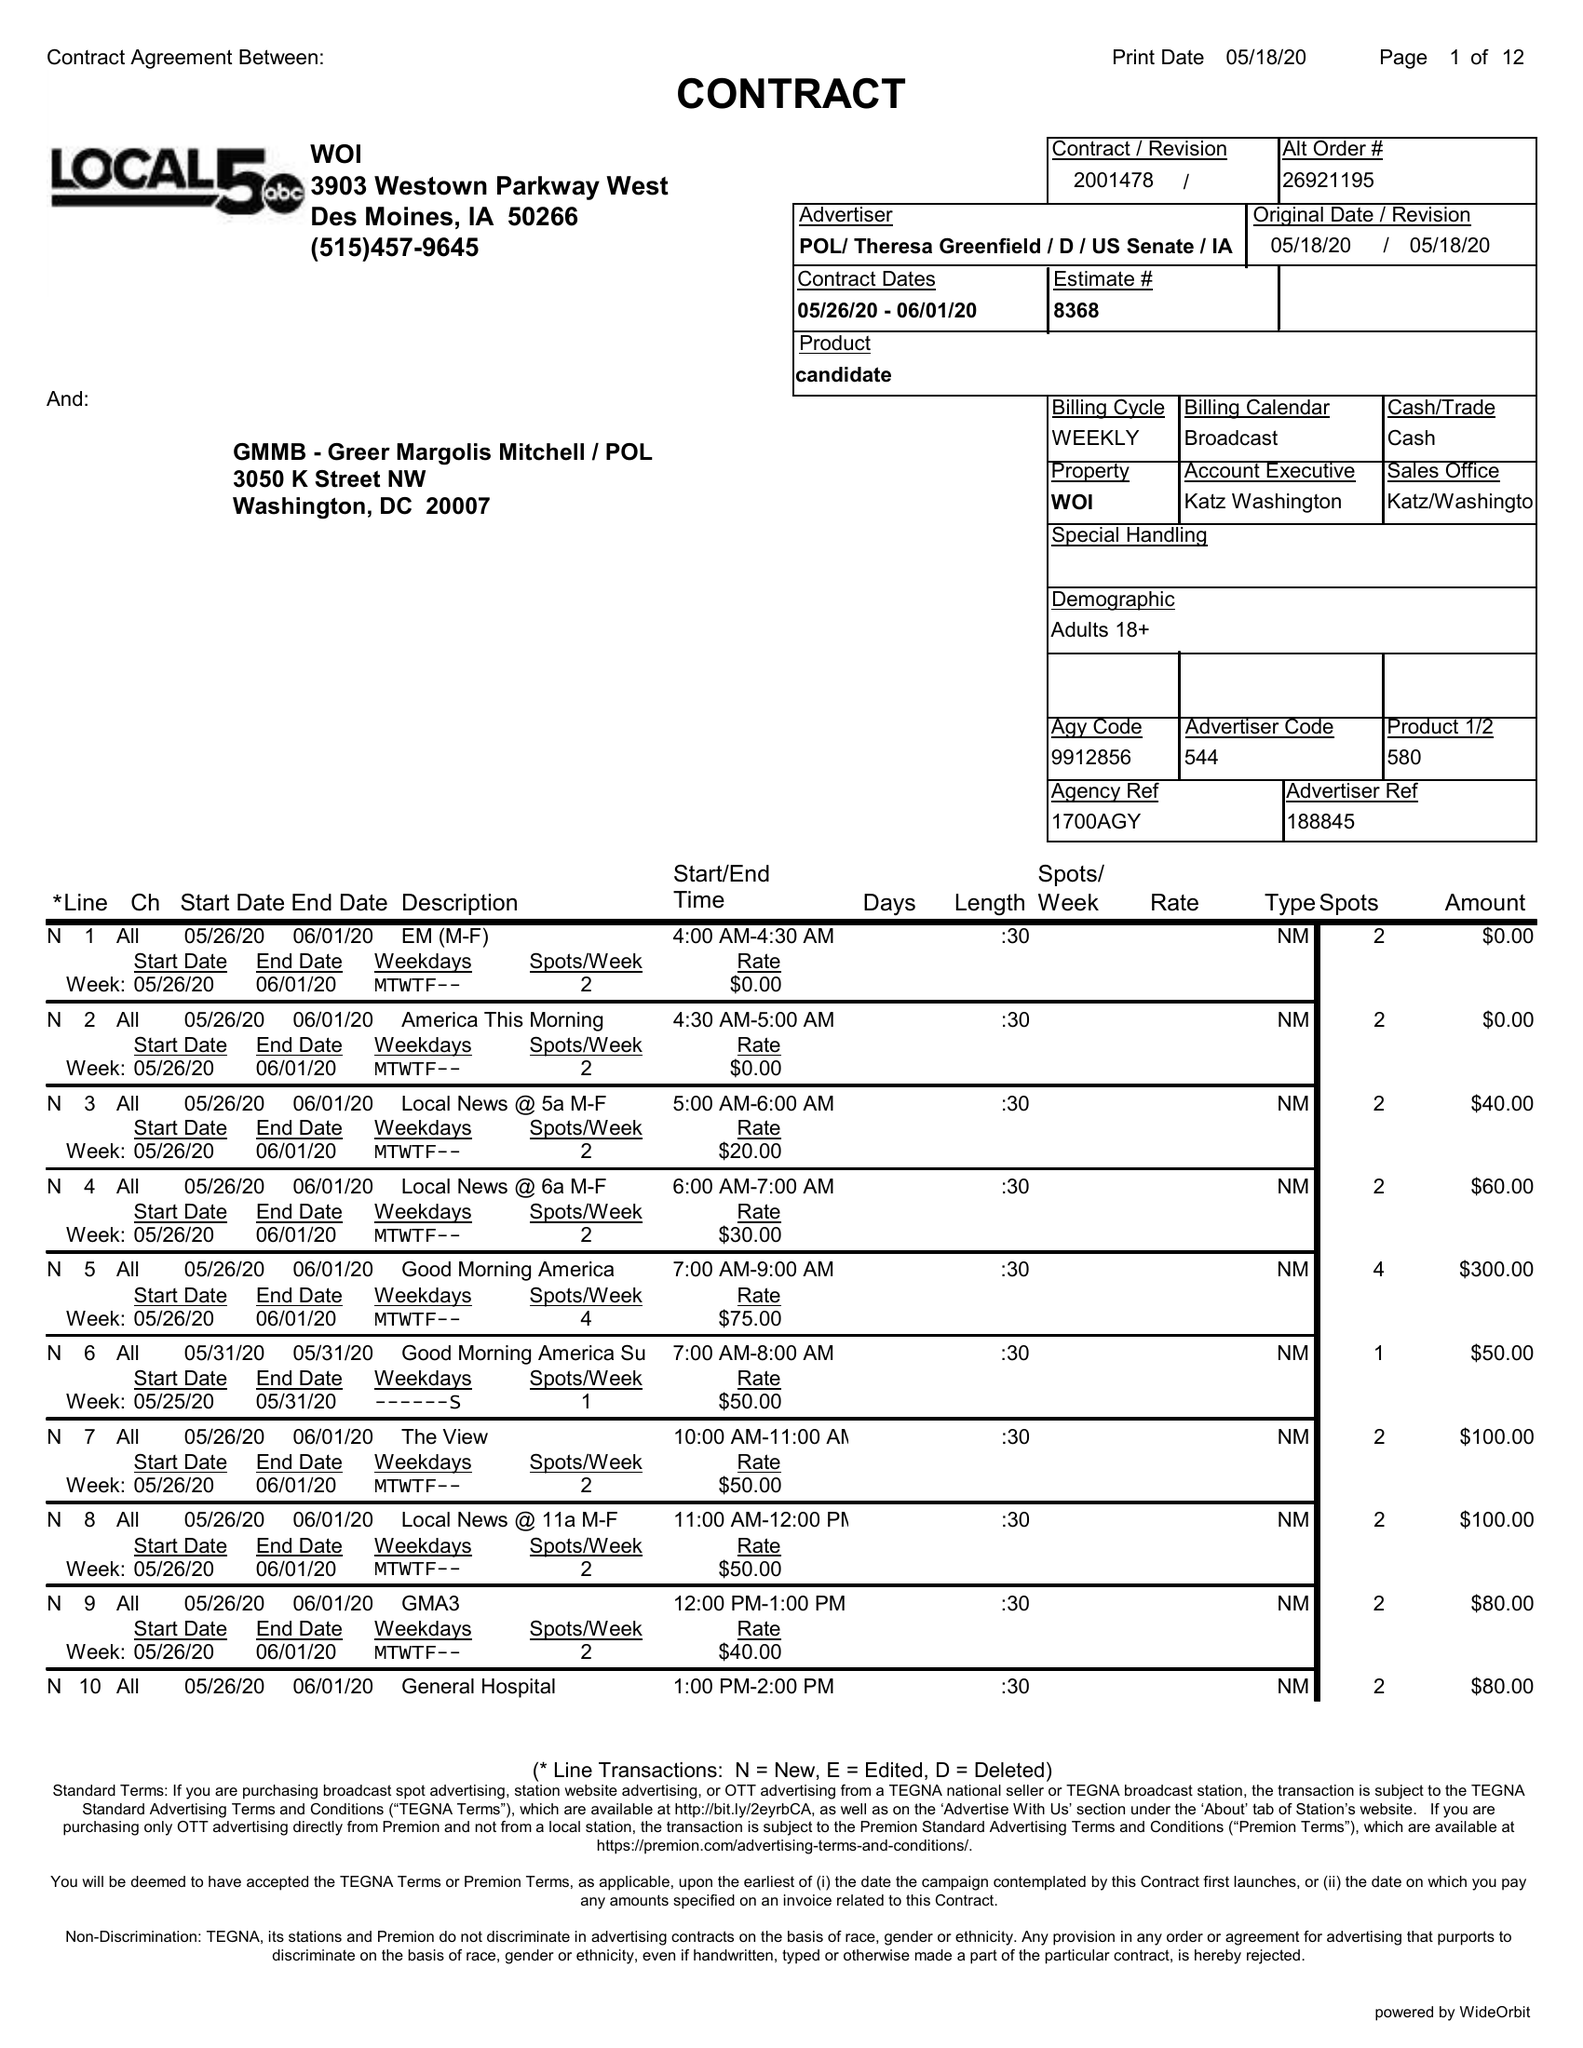What is the value for the gross_amount?
Answer the question using a single word or phrase. 2330.00 